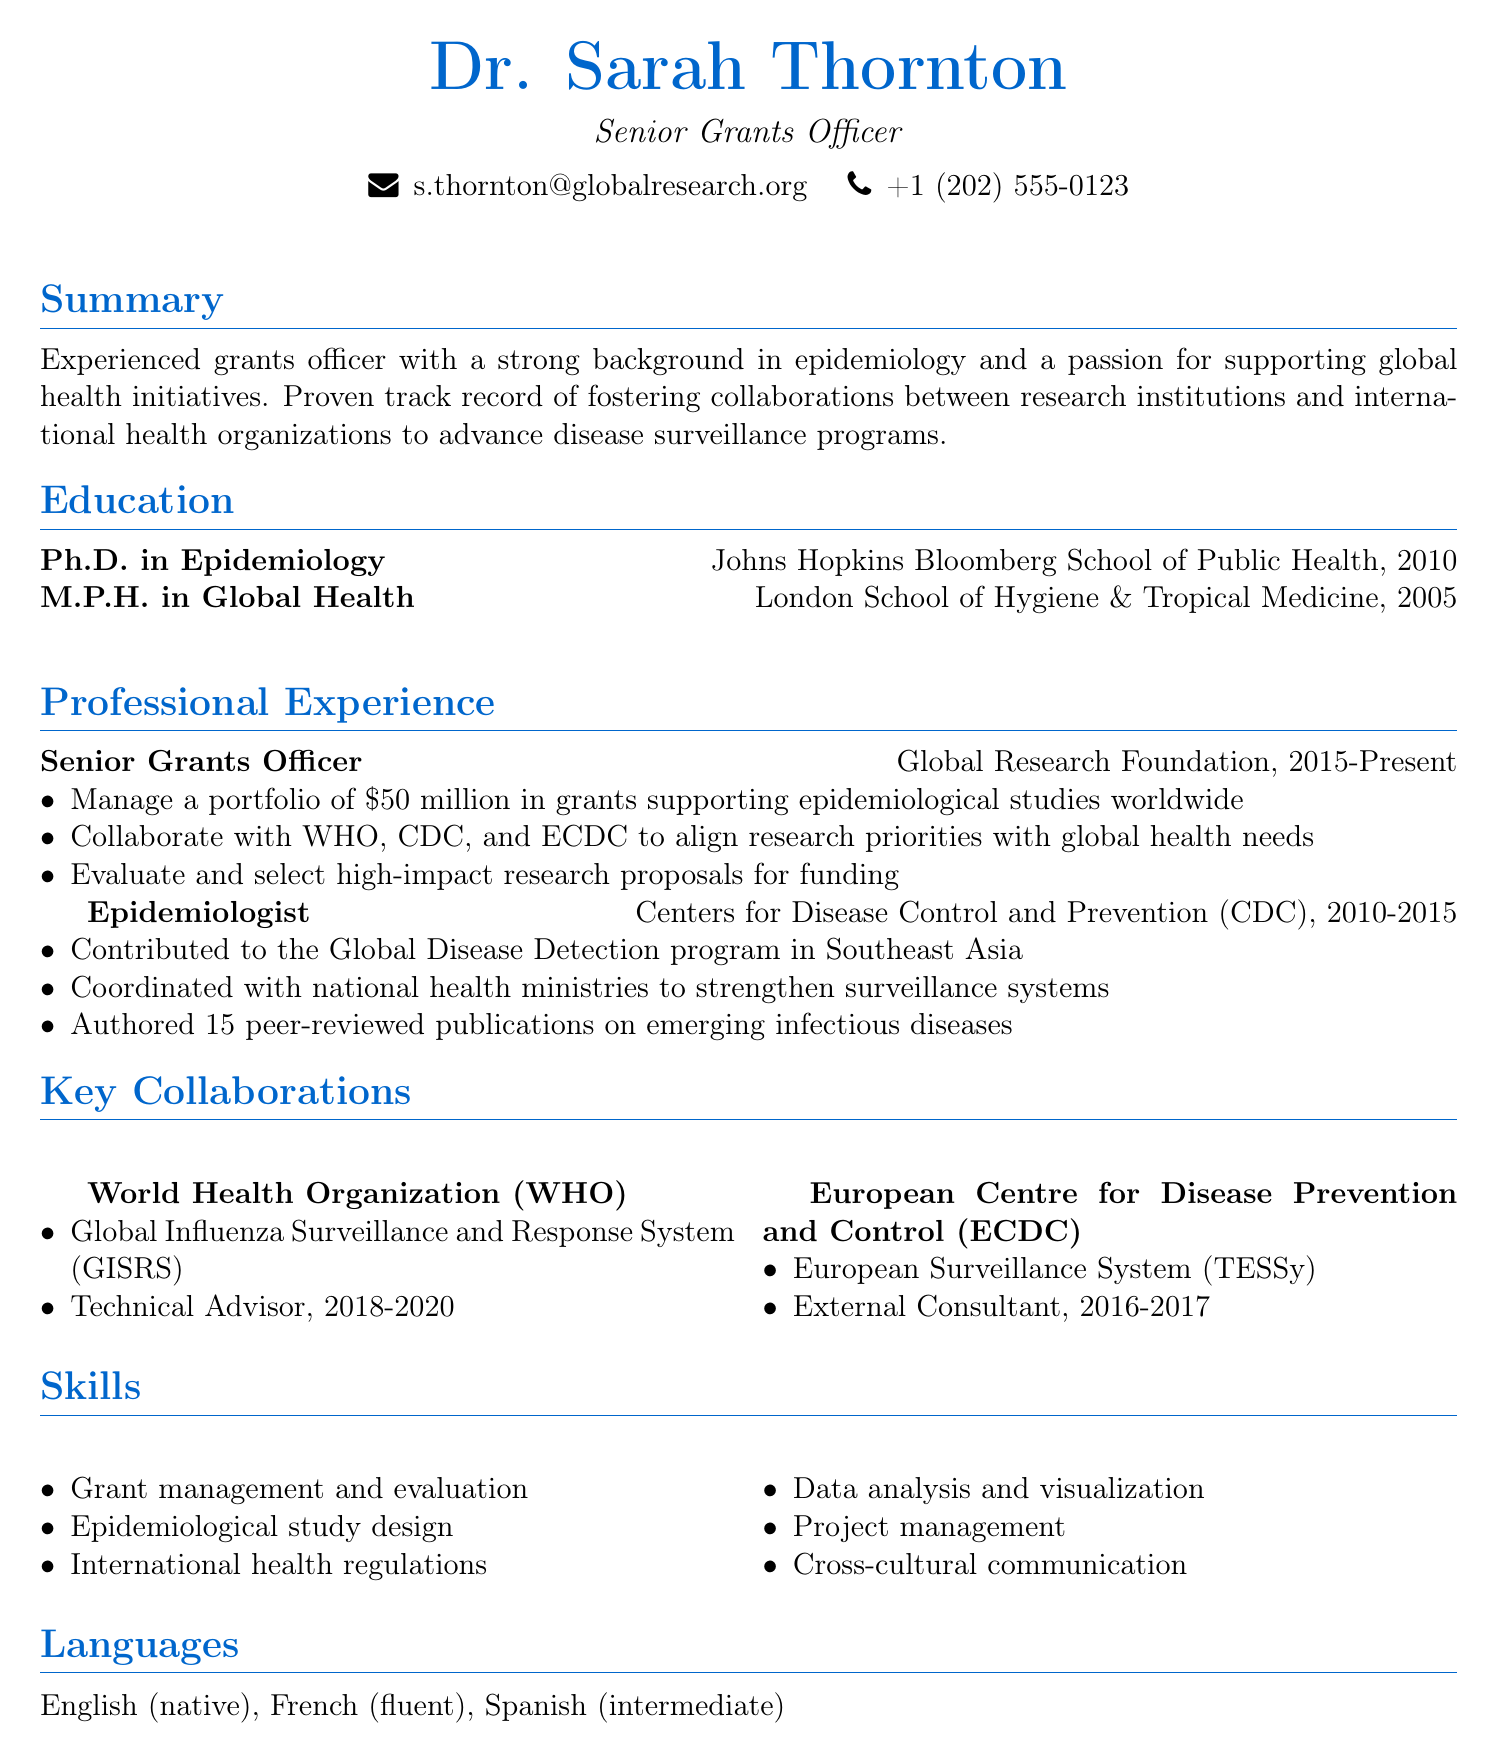What is Dr. Sarah Thornton's current title? The document states that she is a Senior Grants Officer at the Global Research Foundation.
Answer: Senior Grants Officer What year did Dr. Sarah Thornton earn her Ph.D. in Epidemiology? The document indicates that Dr. Sarah Thornton earned her Ph.D. in Epidemiology in 2010.
Answer: 2010 Which international health organization did Dr. Thornton collaborate with for the Global Influenza Surveillance and Response System? The document lists the World Health Organization (WHO) as her collaborating organization for that project.
Answer: World Health Organization (WHO) What is the total amount of grants managed by Dr. Thornton at the Global Research Foundation? The document specifies that she manages a portfolio of $50 million in grants.
Answer: $50 million What role did Dr. Thornton serve in the European Surveillance System project? The document states she was an External Consultant for the ECDC project.
Answer: External Consultant In which region did Dr. Thornton contribute to the Global Disease Detection program? The document mentions that she contributed in Southeast Asia.
Answer: Southeast Asia How many peer-reviewed publications did Dr. Thornton author on emerging infectious diseases? The document indicates that she authored 15 peer-reviewed publications.
Answer: 15 Which degree did Dr. Thornton earn first? The document lists her M.P.H. in Global Health as the first degree she earned in 2005.
Answer: M.P.H. in Global Health What is one of Dr. Thornton's skills related to her work? The document cites "Grant management and evaluation" as one of her skills.
Answer: Grant management and evaluation 